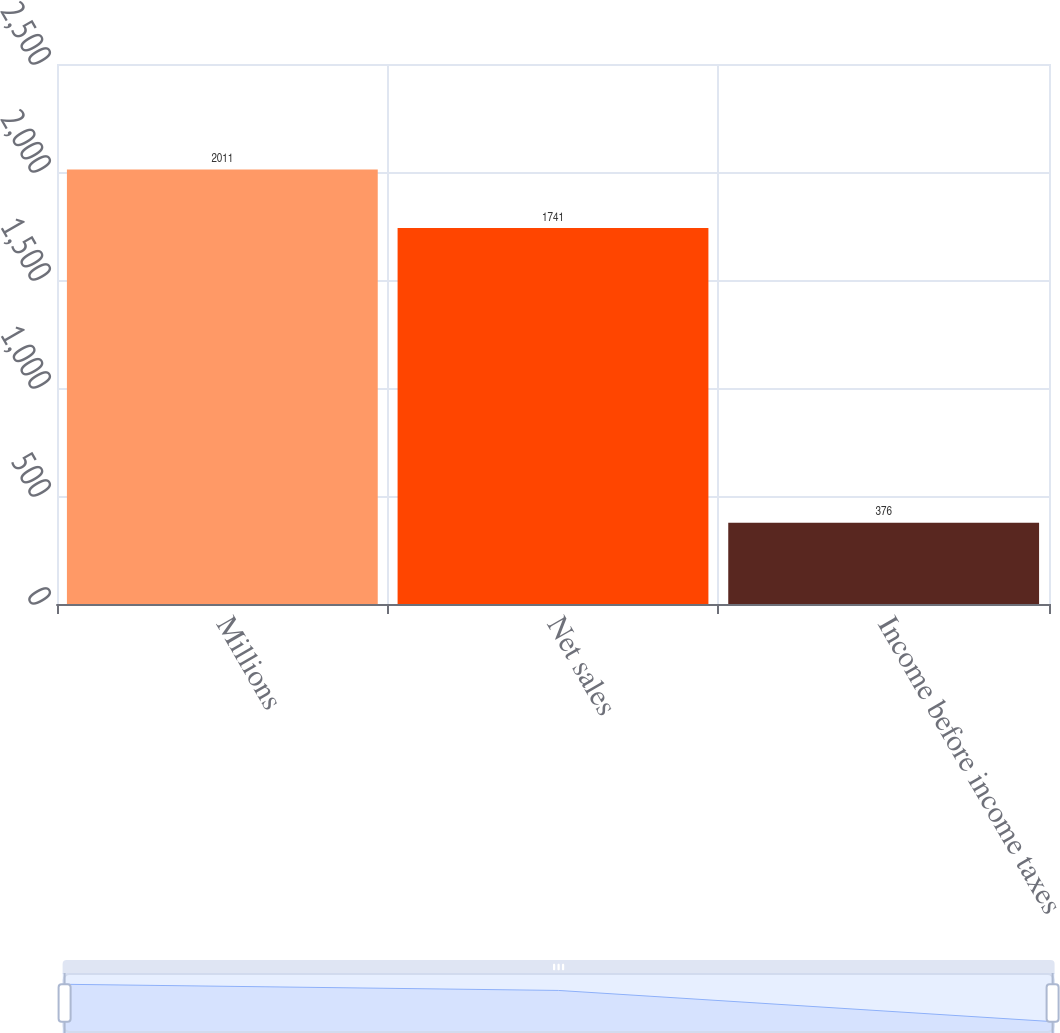Convert chart to OTSL. <chart><loc_0><loc_0><loc_500><loc_500><bar_chart><fcel>Millions<fcel>Net sales<fcel>Income before income taxes<nl><fcel>2011<fcel>1741<fcel>376<nl></chart> 